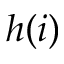<formula> <loc_0><loc_0><loc_500><loc_500>h ( i )</formula> 